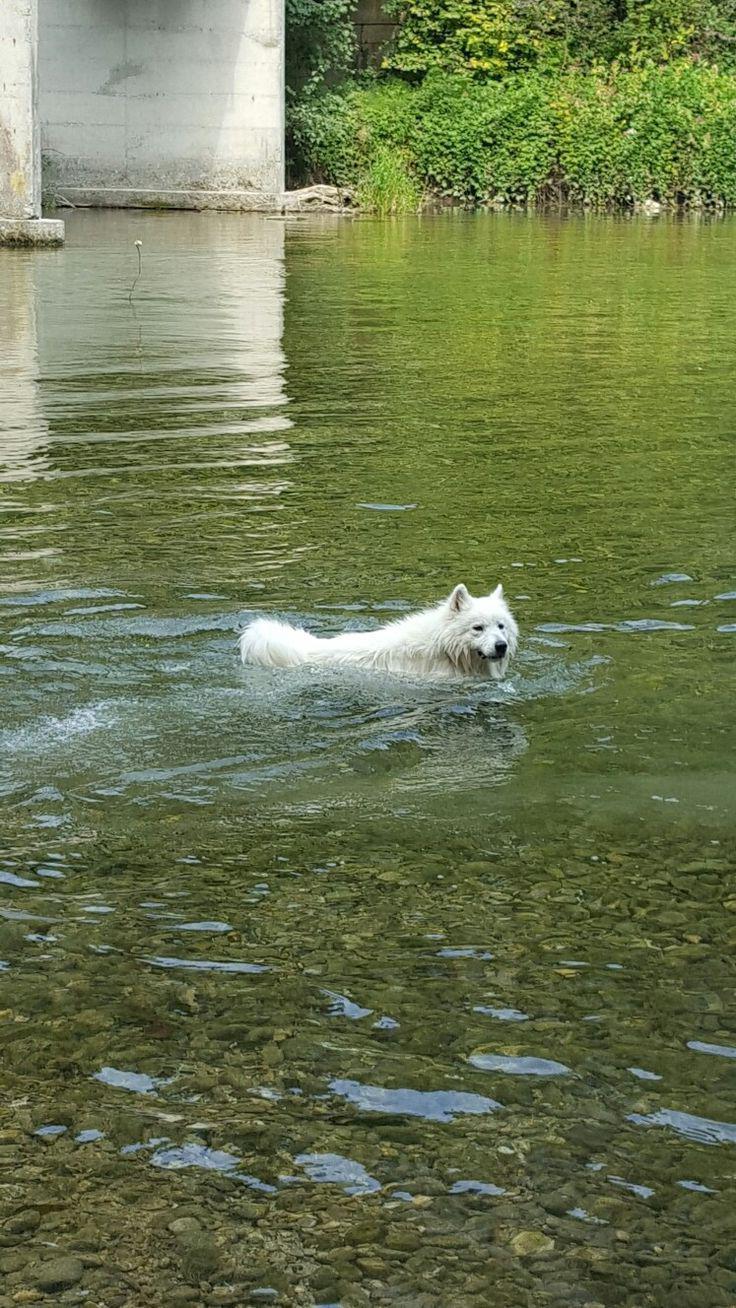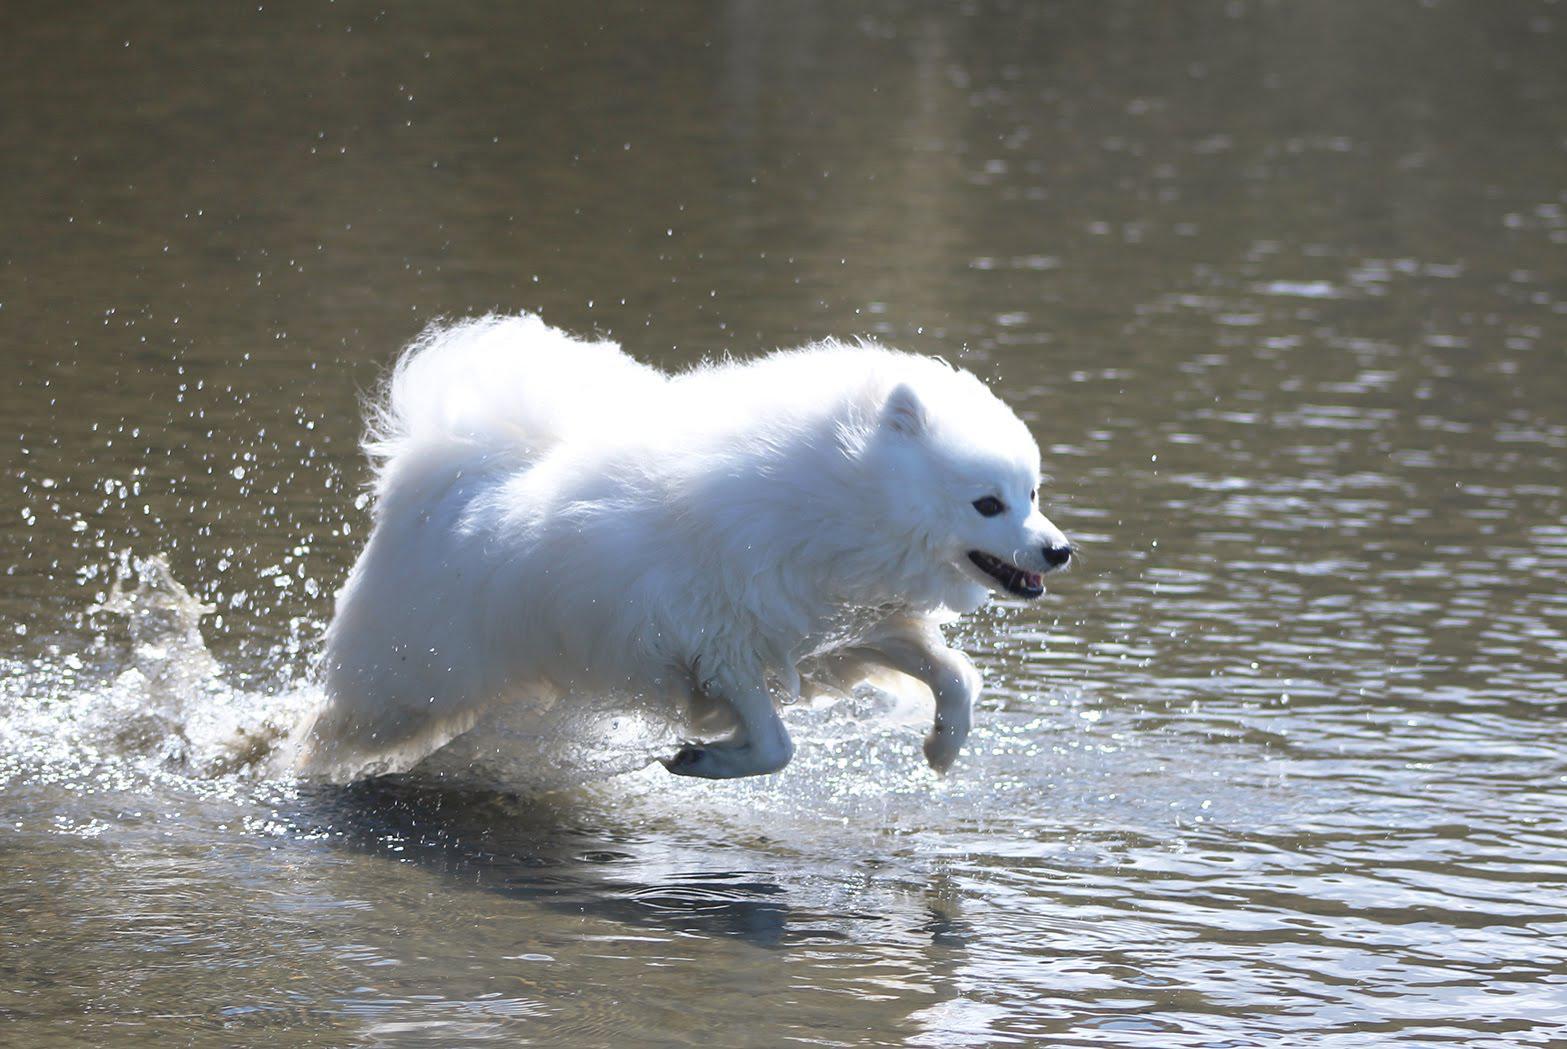The first image is the image on the left, the second image is the image on the right. Given the left and right images, does the statement "There is a human with a white dog surrounded by water in the left image." hold true? Answer yes or no. No. The first image is the image on the left, the second image is the image on the right. Considering the images on both sides, is "There is at least one person visible" valid? Answer yes or no. No. 